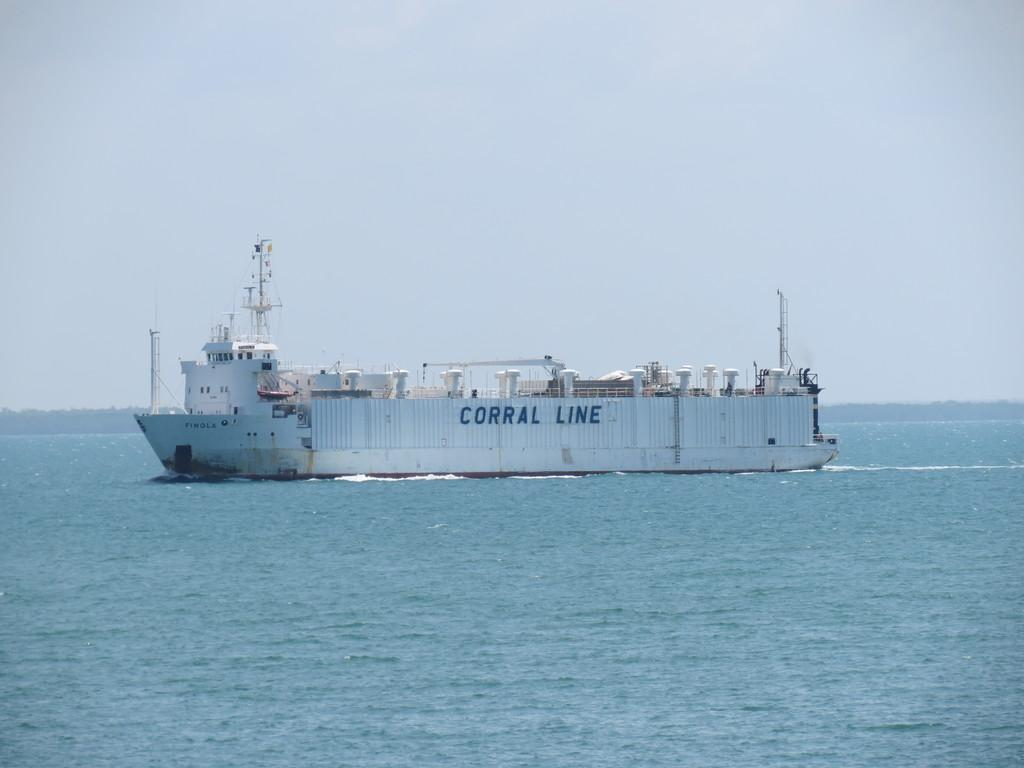What is the main subject of the image? The main subject of the image is water. What is located on the water in the image? There is a boat on the water in the image. What can be seen written in the image? There are words written in the image. What is visible in the background of the image? The sky is visible in the background of the image. What advice does the grandmother give in the image? There is no grandmother present in the image, so it is it is not possible to determine any advice she might give. 